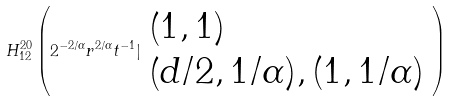<formula> <loc_0><loc_0><loc_500><loc_500>H _ { 1 2 } ^ { 2 0 } \left ( 2 ^ { - 2 / \alpha } r ^ { 2 / \alpha } t ^ { - 1 } | \begin{array} { l } \left ( 1 , 1 \right ) \\ \left ( d / 2 , 1 / \alpha ) , ( 1 , 1 / \alpha \right ) \end{array} \right )</formula> 